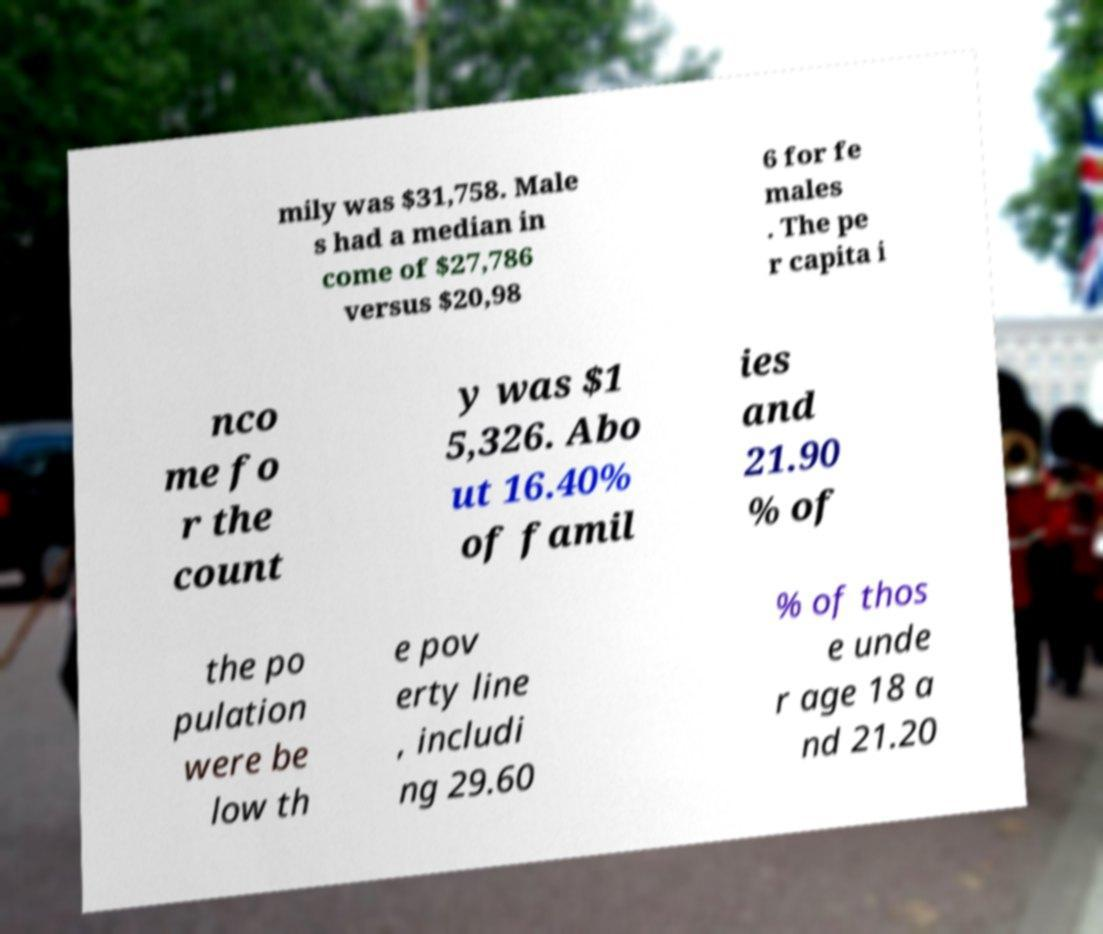Please read and relay the text visible in this image. What does it say? mily was $31,758. Male s had a median in come of $27,786 versus $20,98 6 for fe males . The pe r capita i nco me fo r the count y was $1 5,326. Abo ut 16.40% of famil ies and 21.90 % of the po pulation were be low th e pov erty line , includi ng 29.60 % of thos e unde r age 18 a nd 21.20 